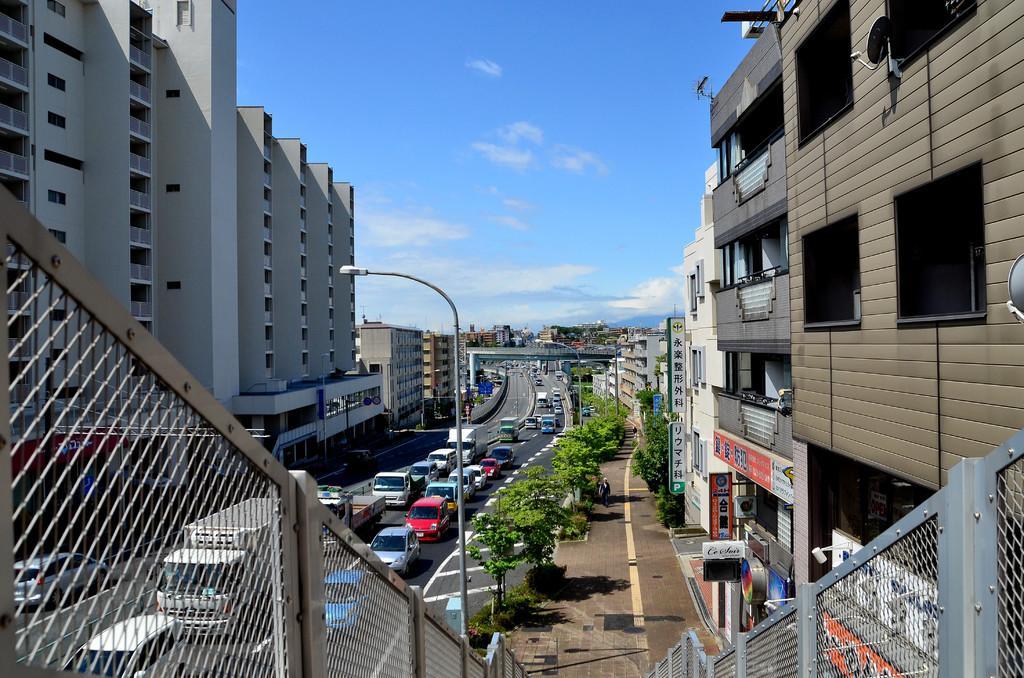Please provide a concise description of this image. In this image there are few vehicles passing on the road, on the either side of the road there are trees, buildings and a lamp post. 